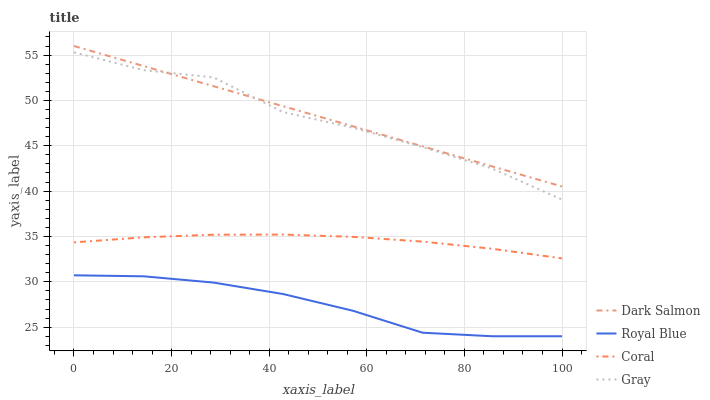Does Royal Blue have the minimum area under the curve?
Answer yes or no. Yes. Does Dark Salmon have the maximum area under the curve?
Answer yes or no. Yes. Does Coral have the minimum area under the curve?
Answer yes or no. No. Does Coral have the maximum area under the curve?
Answer yes or no. No. Is Dark Salmon the smoothest?
Answer yes or no. Yes. Is Gray the roughest?
Answer yes or no. Yes. Is Coral the smoothest?
Answer yes or no. No. Is Coral the roughest?
Answer yes or no. No. Does Royal Blue have the lowest value?
Answer yes or no. Yes. Does Coral have the lowest value?
Answer yes or no. No. Does Dark Salmon have the highest value?
Answer yes or no. Yes. Does Coral have the highest value?
Answer yes or no. No. Is Royal Blue less than Gray?
Answer yes or no. Yes. Is Dark Salmon greater than Coral?
Answer yes or no. Yes. Does Dark Salmon intersect Gray?
Answer yes or no. Yes. Is Dark Salmon less than Gray?
Answer yes or no. No. Is Dark Salmon greater than Gray?
Answer yes or no. No. Does Royal Blue intersect Gray?
Answer yes or no. No. 